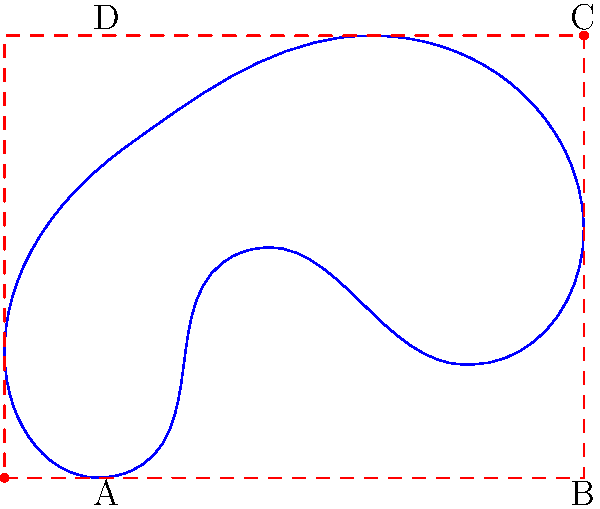In your 3D animation project, you need to create a bounding box for an irregularly shaped 2D object. Given the blue irregular shape in the diagram, what are the dimensions (width and height) of the red dashed rectangular bounding box that fully encloses the object? To determine the dimensions of the bounding box, we need to follow these steps:

1. Identify the minimum and maximum points of the irregular shape:
   - The minimum point (bottom-left corner of the bounding box) is at $(0, 0)$.
   - The maximum point (top-right corner of the bounding box) is at $(4, 4)$.

2. Calculate the width of the bounding box:
   $$\text{Width} = x_{\text{max}} - x_{\text{min}} = 4 - 0 = 4$$

3. Calculate the height of the bounding box:
   $$\text{Height} = y_{\text{max}} - y_{\text{min}} = 4 - 0 = 4$$

4. The dimensions of the bounding box are therefore 4 units wide and 4 units high.

In Blender, you would use these dimensions to create a rectangular plane that fully encloses the irregular object, ensuring that all parts of the object are within the bounding box.
Answer: $4 \times 4$ units 